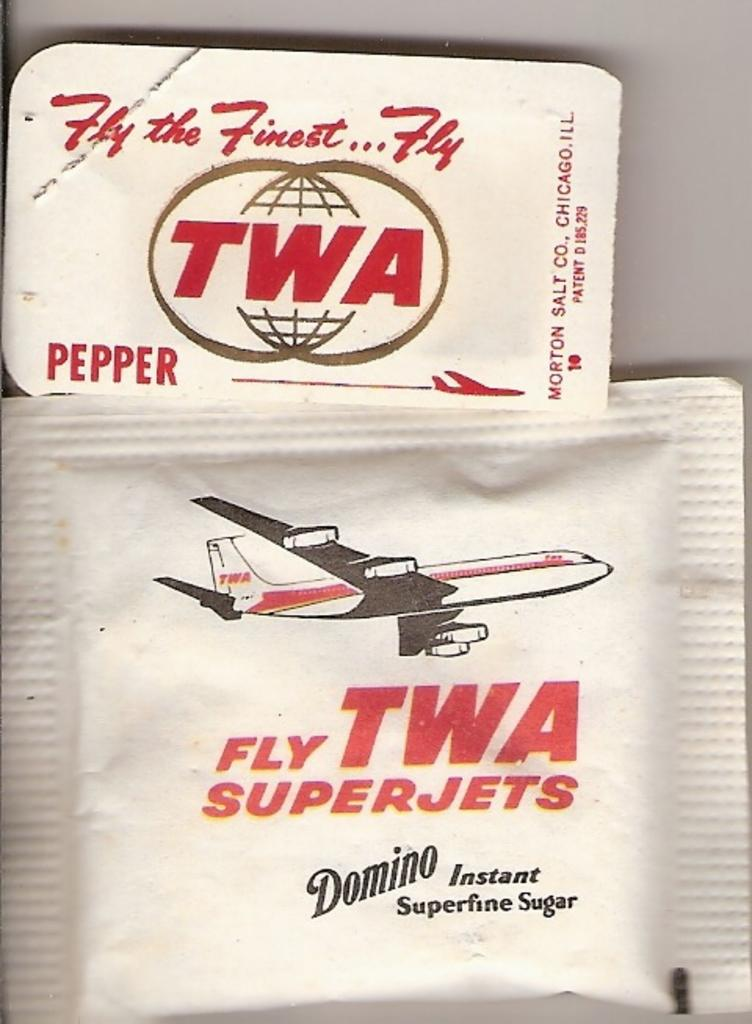<image>
Present a compact description of the photo's key features. A packet of TWA superfine sugar is next to a packet of pepper. 